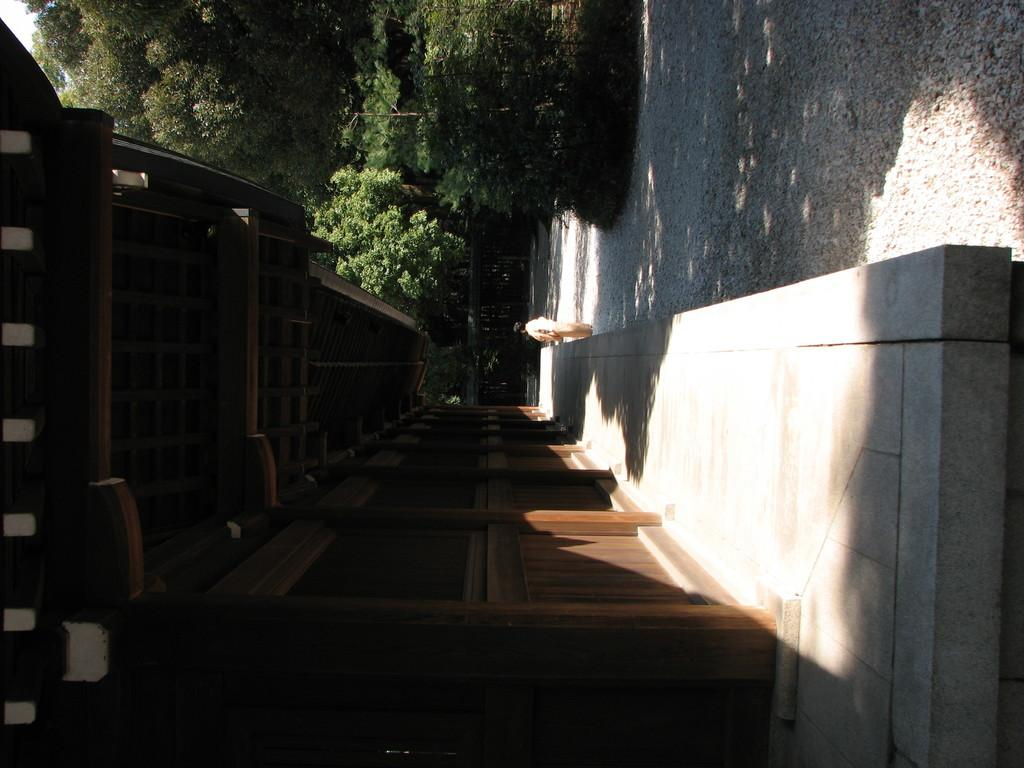What type of wall is present in the image? There is a wooden wall in the image. What is the person in the image standing on? There is a platform in the image. Can you describe the person in the image? There is a person in the image. What can be seen in the background of the image? There are trees visible in the background of the image. What is the shadow on the ground in the image? There is a shadow on the ground in the image. What color of ink is being used by the person in the image? There is no indication of ink or writing in the image, so it is not possible to determine the color of ink being used. How does the platform expand in the image? The platform does not expand in the image; it is a static structure. 